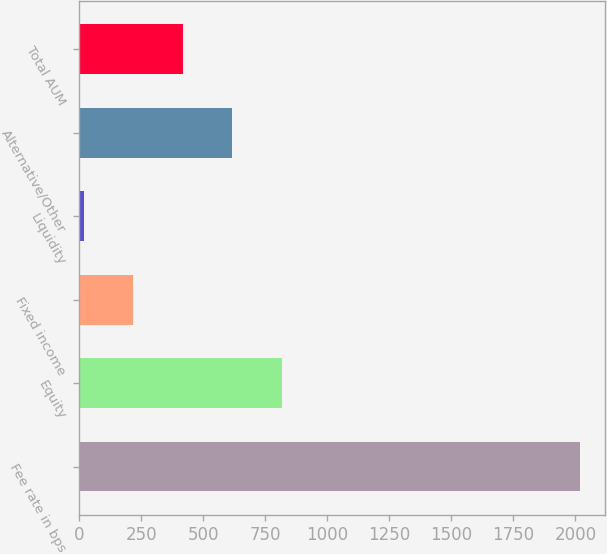Convert chart to OTSL. <chart><loc_0><loc_0><loc_500><loc_500><bar_chart><fcel>Fee rate in bps<fcel>Equity<fcel>Fixed income<fcel>Liquidity<fcel>Alternative/Other<fcel>Total AUM<nl><fcel>2017<fcel>817<fcel>217<fcel>17<fcel>617<fcel>417<nl></chart> 